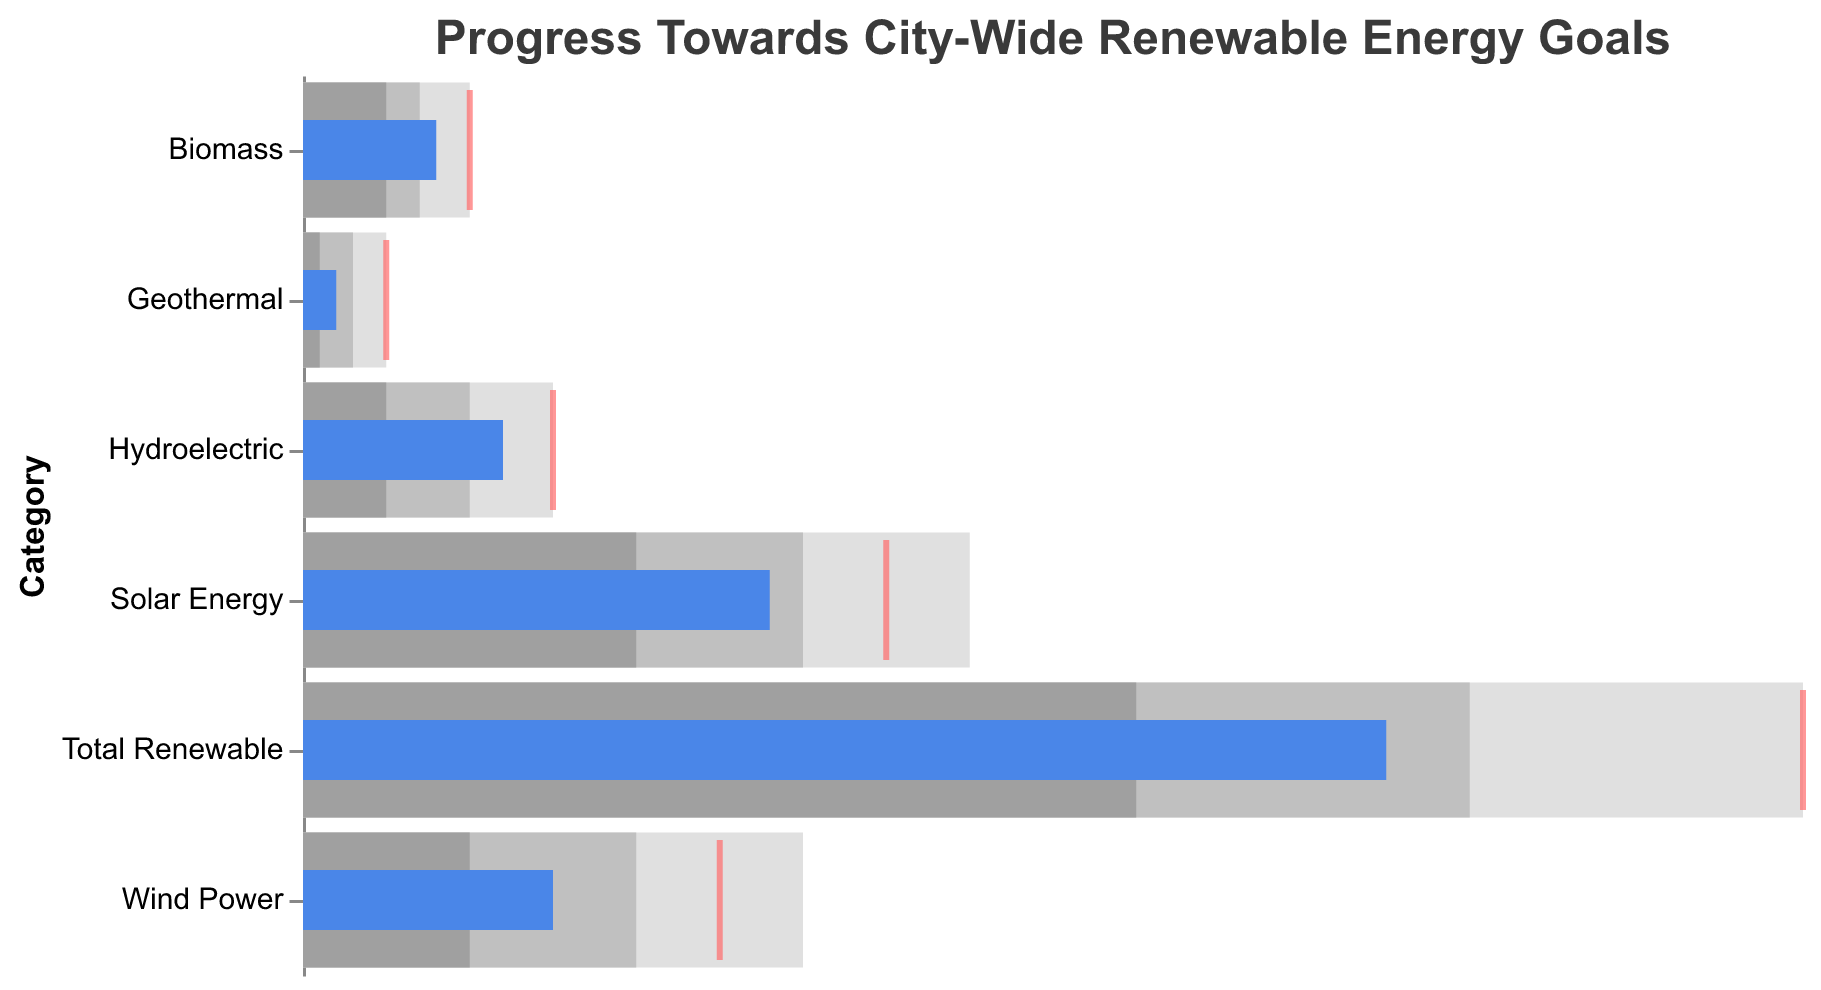What is the title of the chart? The title is presented at the top of the chart. It helps to understand what the chart is about by summarizing its main topic.
Answer: Progress Towards City-Wide Renewable Energy Goals What is the actual percentage of Solar Energy achieved? Look for the bar labeled "Solar Energy" and refer to the blue bar's length corresponding to the "Actual" percentage.
Answer: 28% What is the target percentage for Total Renewable energy? Identify the "Total Renewable" category and examine the red tick mark which indicates the target percentage.
Answer: 90% How far is Wind Power from its target in percentage terms? Find the "Wind Power" category. The actual achieved percentage is 15%, and the target is 25%. Calculate the difference.
Answer: 10% Which energy category is closest to its target? Compare the distances between the actual percentages (blue bar) and target percentages (red ticks) for all categories. Hydroelectric is closest to its target (12% actual vs. 15% target).
Answer: Hydroelectric What is the sum of the actual percentages for Solar Energy and Wind Power? Add the actual percentages of these two categories: 28% (Solar Energy) + 15% (Wind Power).
Answer: 43% Which category has the largest range between Range1 and Range3? Examine the values for Range1 and Range3 for each category, and calculate the differences to find the largest one.
Answer: Solar Energy Does Biomass reach its target? Biomass's actual percentage is 8%, and its target is 10%. Since the actual is less than the target, Biomass doesn't reach its target.
Answer: No What range does Hydroelectric fall into based on its actual achievement? The blue bar for Hydroelectric falls within the ranges shown in different shades of gray. The actual value of 12% falls into the Range3 category (10-15%).
Answer: 10-15% Which energy category has the lowest actual percentage? Compare the actual percentages (blue bars) for all categories. Geothermal has the lowest actual achievement at 2%.
Answer: Geothermal 